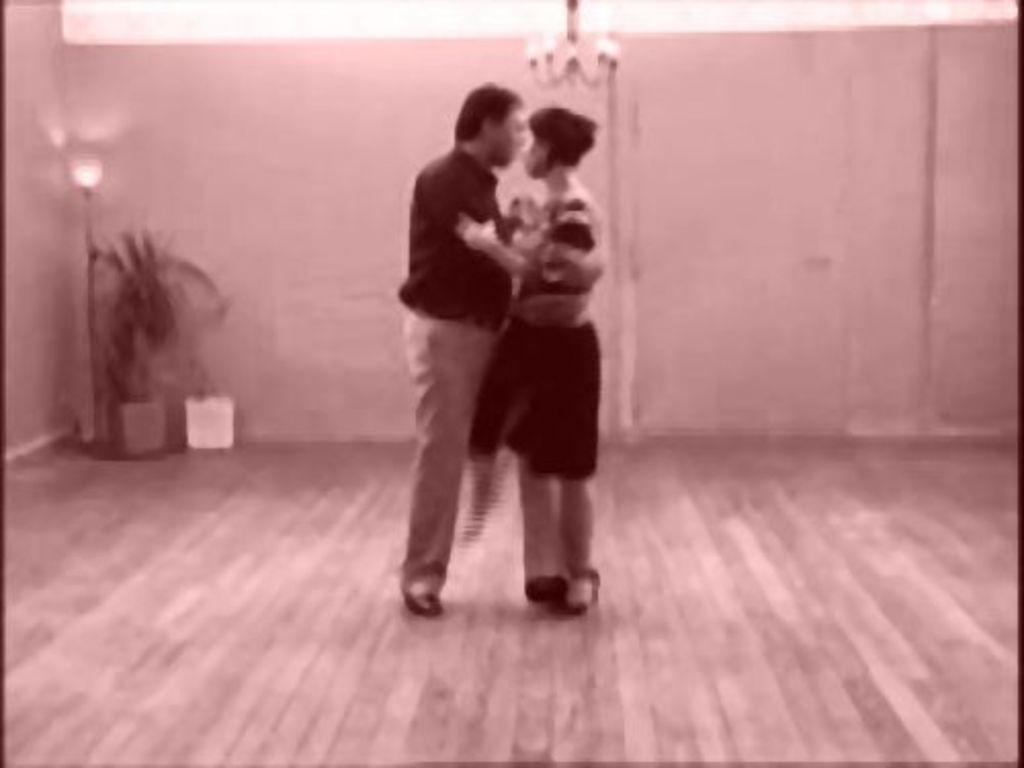What can be seen in the image, despite the blurriness? There are people, a plant with a pot, a white object, light, and a wall in the background visible in the image. Can you describe the plant in the image? The plant is in a pot, although the image is blurry, so it's difficult to provide more details about the plant itself. What color is the white object in the image? The white object is white, as mentioned in the fact. What is the source of light in the image? The presence of light in the image is mentioned, but the source of light is not specified. What nation is represented by the flag in the image? There is no flag present in the image, so it's not possible to determine which nation might be represented. What time of day is depicted in the image? The time of day is not specified in the image, so it's not possible to determine whether it's morning or any other time of day. 